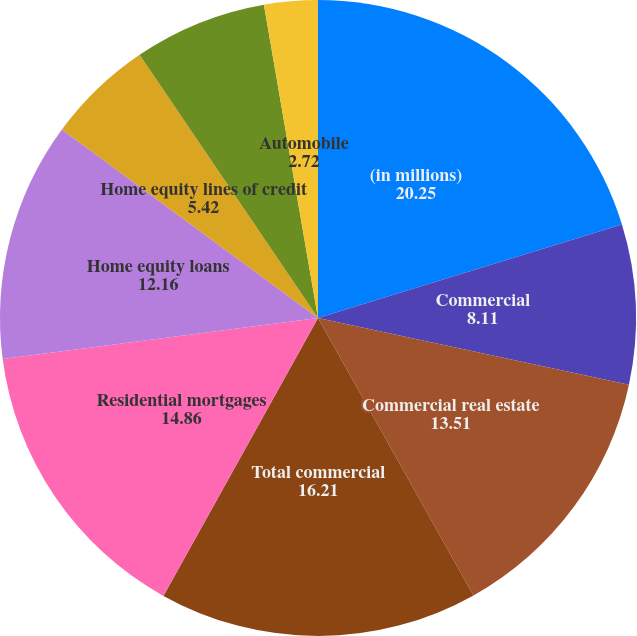<chart> <loc_0><loc_0><loc_500><loc_500><pie_chart><fcel>(in millions)<fcel>Commercial<fcel>Commercial real estate<fcel>Total commercial<fcel>Residential mortgages<fcel>Home equity loans<fcel>Home equity lines of credit<fcel>Home equity loans serviced by<fcel>Automobile<nl><fcel>20.25%<fcel>8.11%<fcel>13.51%<fcel>16.21%<fcel>14.86%<fcel>12.16%<fcel>5.42%<fcel>6.76%<fcel>2.72%<nl></chart> 